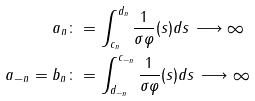Convert formula to latex. <formula><loc_0><loc_0><loc_500><loc_500>a _ { n } & \colon = \int _ { c _ { n } } ^ { d _ { n } } \frac { 1 } { \sigma \varphi } ( s ) d s \, \longrightarrow \infty \\ a _ { - n } = b _ { n } & \colon = \int ^ { c _ { - n } } _ { d _ { - n } } \frac { 1 } { \sigma \varphi } ( s ) d s \, \longrightarrow \infty</formula> 